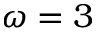Convert formula to latex. <formula><loc_0><loc_0><loc_500><loc_500>\omega = 3</formula> 